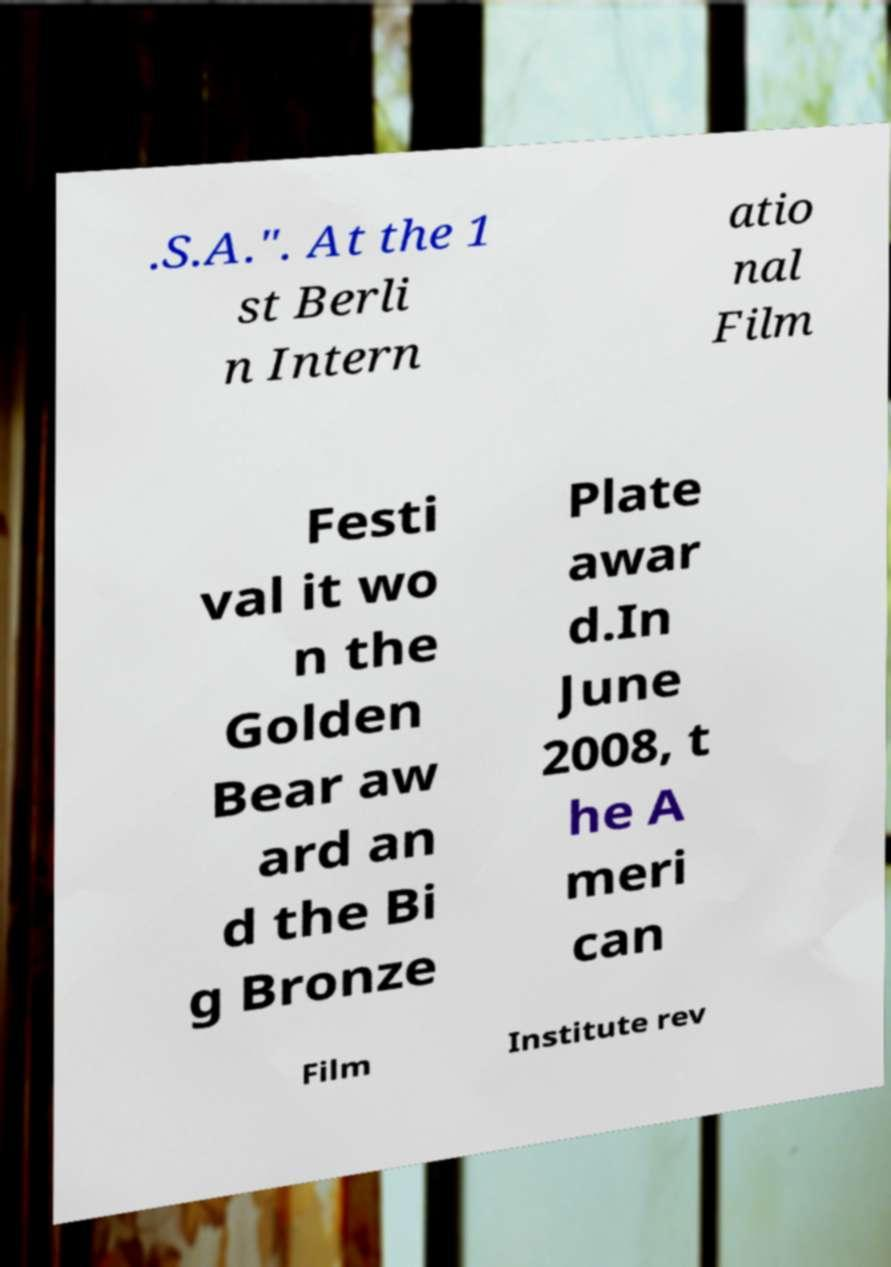Please identify and transcribe the text found in this image. .S.A.". At the 1 st Berli n Intern atio nal Film Festi val it wo n the Golden Bear aw ard an d the Bi g Bronze Plate awar d.In June 2008, t he A meri can Film Institute rev 